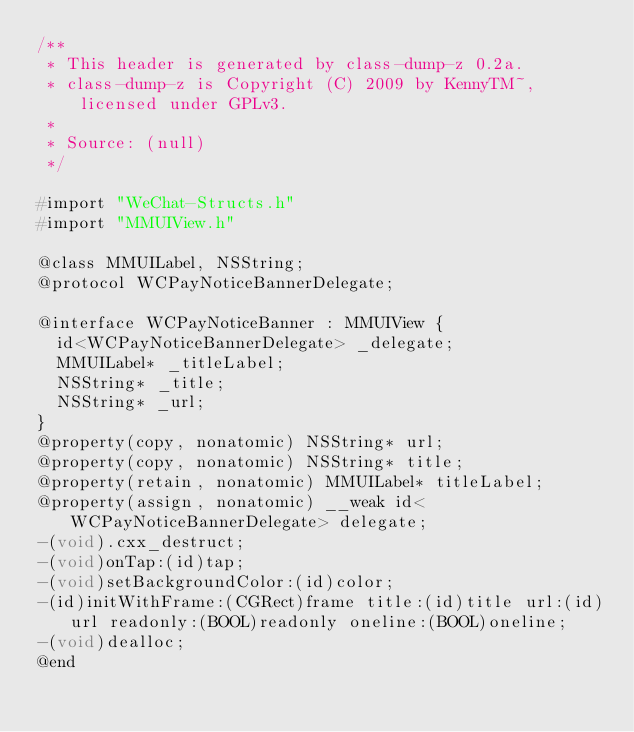<code> <loc_0><loc_0><loc_500><loc_500><_C_>/**
 * This header is generated by class-dump-z 0.2a.
 * class-dump-z is Copyright (C) 2009 by KennyTM~, licensed under GPLv3.
 *
 * Source: (null)
 */

#import "WeChat-Structs.h"
#import "MMUIView.h"

@class MMUILabel, NSString;
@protocol WCPayNoticeBannerDelegate;

@interface WCPayNoticeBanner : MMUIView {
	id<WCPayNoticeBannerDelegate> _delegate;
	MMUILabel* _titleLabel;
	NSString* _title;
	NSString* _url;
}
@property(copy, nonatomic) NSString* url;
@property(copy, nonatomic) NSString* title;
@property(retain, nonatomic) MMUILabel* titleLabel;
@property(assign, nonatomic) __weak id<WCPayNoticeBannerDelegate> delegate;
-(void).cxx_destruct;
-(void)onTap:(id)tap;
-(void)setBackgroundColor:(id)color;
-(id)initWithFrame:(CGRect)frame title:(id)title url:(id)url readonly:(BOOL)readonly oneline:(BOOL)oneline;
-(void)dealloc;
@end

</code> 